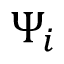<formula> <loc_0><loc_0><loc_500><loc_500>\Psi _ { i }</formula> 